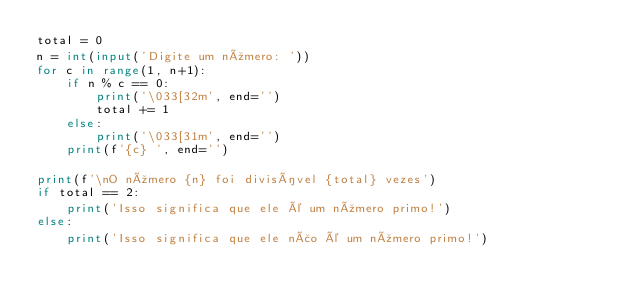Convert code to text. <code><loc_0><loc_0><loc_500><loc_500><_Python_>total = 0
n = int(input('Digite um número: '))
for c in range(1, n+1):
    if n % c == 0:
        print('\033[32m', end='')
        total += 1
    else:
        print('\033[31m', end='')
    print(f'{c} ', end='')

print(f'\nO número {n} foi divisível {total} vezes')
if total == 2:
    print('Isso significa que ele é um número primo!')
else:
    print('Isso significa que ele não é um número primo!')</code> 